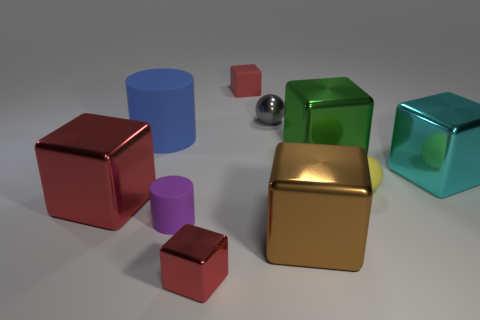There is a large object that is the same color as the tiny metal block; what material is it?
Your answer should be very brief. Metal. Is the blue cylinder the same size as the cyan metal block?
Make the answer very short. Yes. Is there a object right of the red object that is behind the tiny yellow object?
Provide a succinct answer. Yes. There is another shiny block that is the same color as the tiny metal cube; what size is it?
Give a very brief answer. Large. What is the shape of the tiny red object that is in front of the large cyan metal block?
Your response must be concise. Cube. There is a cube behind the gray shiny sphere that is right of the small metallic block; how many small red blocks are in front of it?
Ensure brevity in your answer.  1. There is a cyan object; is its size the same as the red block that is behind the big cylinder?
Provide a succinct answer. No. What size is the matte cylinder in front of the big shiny cube that is right of the small yellow sphere?
Your response must be concise. Small. How many spheres are the same material as the big blue thing?
Offer a terse response. 1. Is there a small shiny ball?
Make the answer very short. Yes. 